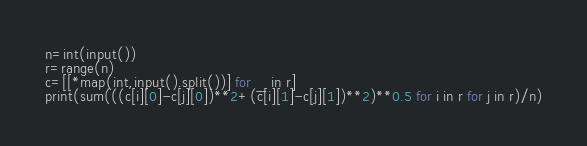<code> <loc_0><loc_0><loc_500><loc_500><_Python_>n=int(input())
r=range(n)
c=[[*map(int,input().split())] for _ in r]
print(sum(((c[i][0]-c[j][0])**2+(c[i][1]-c[j][1])**2)**0.5 for i in r for j in r)/n)</code> 